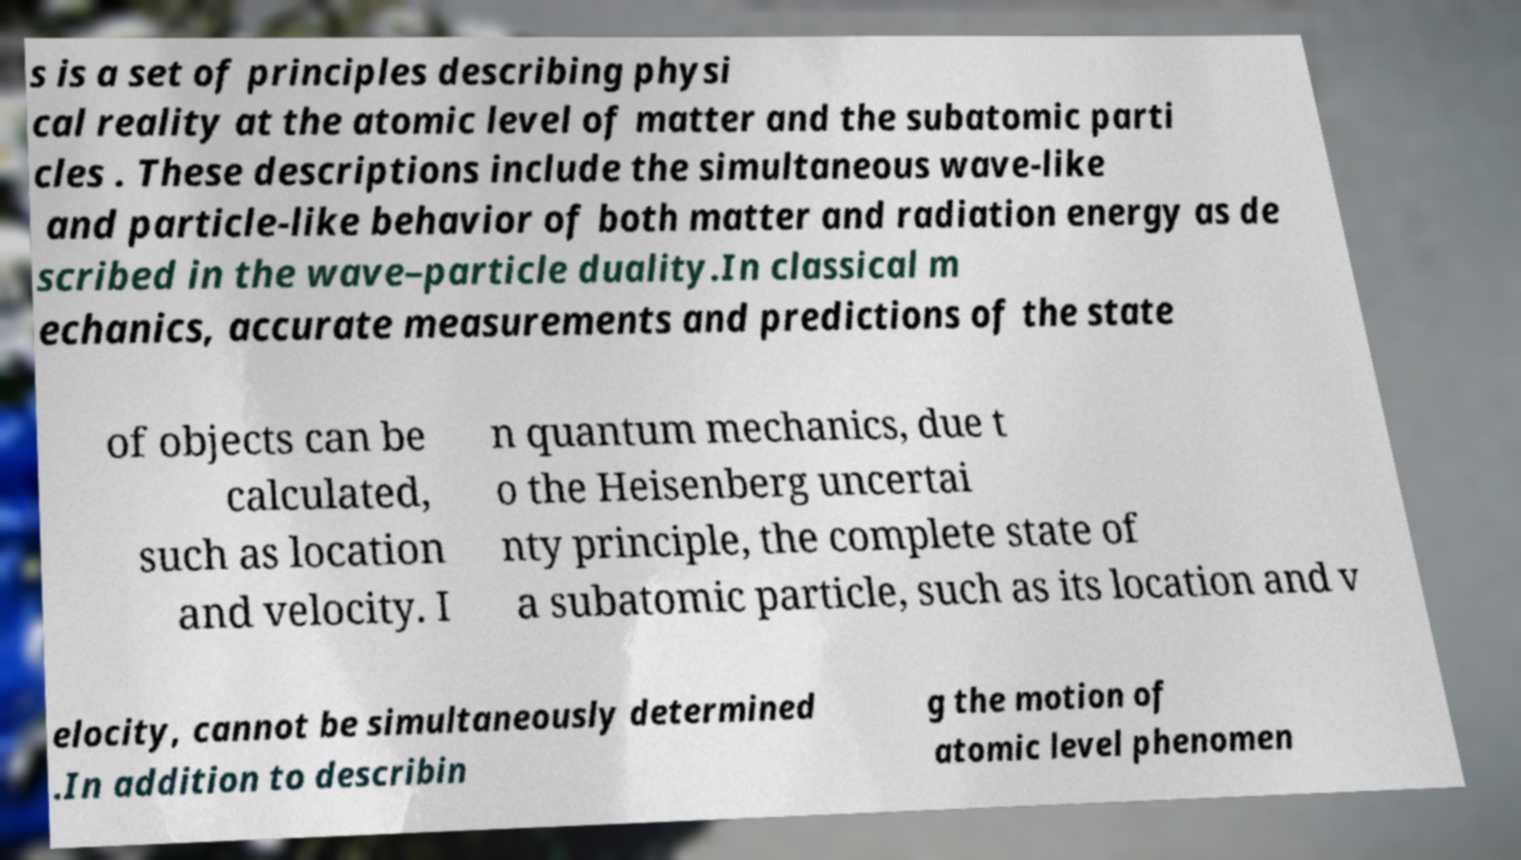For documentation purposes, I need the text within this image transcribed. Could you provide that? s is a set of principles describing physi cal reality at the atomic level of matter and the subatomic parti cles . These descriptions include the simultaneous wave-like and particle-like behavior of both matter and radiation energy as de scribed in the wave–particle duality.In classical m echanics, accurate measurements and predictions of the state of objects can be calculated, such as location and velocity. I n quantum mechanics, due t o the Heisenberg uncertai nty principle, the complete state of a subatomic particle, such as its location and v elocity, cannot be simultaneously determined .In addition to describin g the motion of atomic level phenomen 